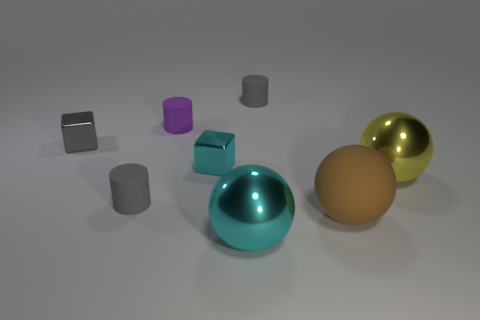Can you describe the colors of the objects in the image? Certainly! The image features objects with a variety of colors. There is a large rubber ball that has a teal hue, another rubber ball with a golden sheen, and a third ball with a matte, earthy tone. Additionally, there are multiple cylinders: one is a light gray, another is a darker shade of gray almost appearing silver, and there's a tiny rubber cylinder with a vibrant purple color. Furthermore, there is a cube with a reflective silver finish. 